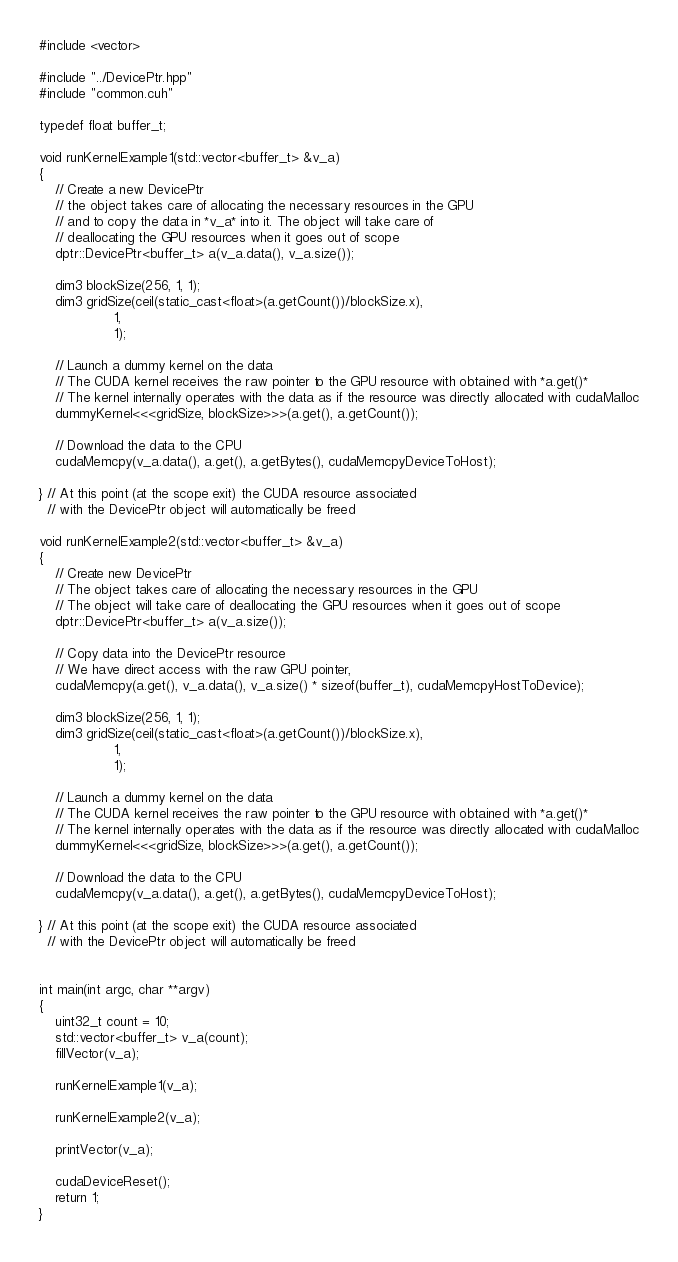<code> <loc_0><loc_0><loc_500><loc_500><_Cuda_>#include <vector>

#include "../DevicePtr.hpp"
#include "common.cuh"

typedef float buffer_t;

void runKernelExample1(std::vector<buffer_t> &v_a)
{
    // Create a new DevicePtr
    // the object takes care of allocating the necessary resources in the GPU
    // and to copy the data in *v_a* into it. The object will take care of
    // deallocating the GPU resources when it goes out of scope
    dptr::DevicePtr<buffer_t> a(v_a.data(), v_a.size());

    dim3 blockSize(256, 1, 1);
    dim3 gridSize(ceil(static_cast<float>(a.getCount())/blockSize.x),
                  1,
                  1);

    // Launch a dummy kernel on the data
    // The CUDA kernel receives the raw pointer to the GPU resource with obtained with *a.get()*
    // The kernel internally operates with the data as if the resource was directly allocated with cudaMalloc
    dummyKernel<<<gridSize, blockSize>>>(a.get(), a.getCount());

    // Download the data to the CPU
    cudaMemcpy(v_a.data(), a.get(), a.getBytes(), cudaMemcpyDeviceToHost);

} // At this point (at the scope exit) the CUDA resource associated
  // with the DevicePtr object will automatically be freed

void runKernelExample2(std::vector<buffer_t> &v_a)
{
    // Create new DevicePtr
    // The object takes care of allocating the necessary resources in the GPU
    // The object will take care of deallocating the GPU resources when it goes out of scope
    dptr::DevicePtr<buffer_t> a(v_a.size());

    // Copy data into the DevicePtr resource
    // We have direct access with the raw GPU pointer,
    cudaMemcpy(a.get(), v_a.data(), v_a.size() * sizeof(buffer_t), cudaMemcpyHostToDevice);

    dim3 blockSize(256, 1, 1);
    dim3 gridSize(ceil(static_cast<float>(a.getCount())/blockSize.x),
                  1,
                  1);

    // Launch a dummy kernel on the data
    // The CUDA kernel receives the raw pointer to the GPU resource with obtained with *a.get()*
    // The kernel internally operates with the data as if the resource was directly allocated with cudaMalloc
    dummyKernel<<<gridSize, blockSize>>>(a.get(), a.getCount());

    // Download the data to the CPU
    cudaMemcpy(v_a.data(), a.get(), a.getBytes(), cudaMemcpyDeviceToHost);

} // At this point (at the scope exit) the CUDA resource associated
  // with the DevicePtr object will automatically be freed


int main(int argc, char **argv)
{
    uint32_t count = 10;
    std::vector<buffer_t> v_a(count);
    fillVector(v_a);

    runKernelExample1(v_a);

    runKernelExample2(v_a);

    printVector(v_a);

    cudaDeviceReset();
    return 1;
}
</code> 